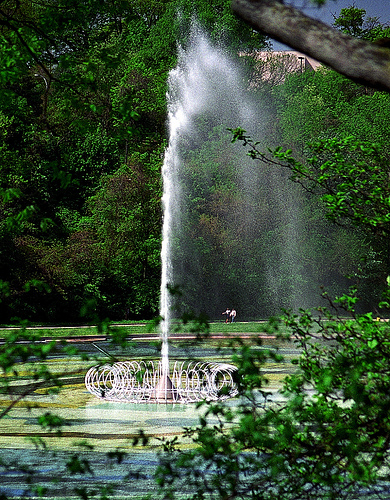<image>
Is the water behind the tree? Yes. From this viewpoint, the water is positioned behind the tree, with the tree partially or fully occluding the water. 